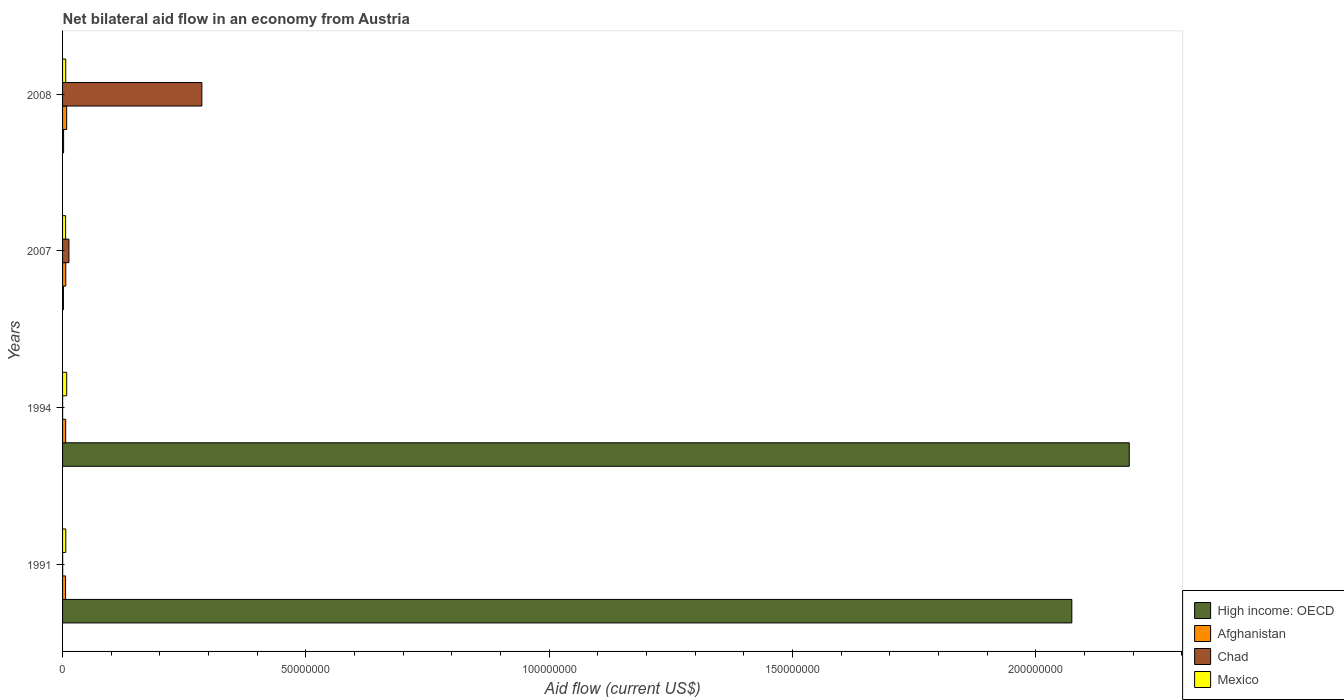How many different coloured bars are there?
Provide a succinct answer. 4. Are the number of bars per tick equal to the number of legend labels?
Provide a succinct answer. Yes. How many bars are there on the 4th tick from the bottom?
Offer a terse response. 4. What is the label of the 4th group of bars from the top?
Keep it short and to the point. 1991. In how many cases, is the number of bars for a given year not equal to the number of legend labels?
Provide a short and direct response. 0. Across all years, what is the maximum net bilateral aid flow in High income: OECD?
Ensure brevity in your answer.  2.19e+08. Across all years, what is the minimum net bilateral aid flow in Mexico?
Keep it short and to the point. 6.30e+05. In which year was the net bilateral aid flow in Afghanistan minimum?
Keep it short and to the point. 1991. What is the total net bilateral aid flow in Chad in the graph?
Ensure brevity in your answer.  3.00e+07. What is the difference between the net bilateral aid flow in Afghanistan in 1991 and that in 2008?
Make the answer very short. -2.20e+05. What is the difference between the net bilateral aid flow in Chad in 2008 and the net bilateral aid flow in Mexico in 2007?
Offer a terse response. 2.80e+07. What is the average net bilateral aid flow in Afghanistan per year?
Offer a terse response. 6.90e+05. In the year 1994, what is the difference between the net bilateral aid flow in Chad and net bilateral aid flow in Afghanistan?
Keep it short and to the point. -6.30e+05. What is the ratio of the net bilateral aid flow in Chad in 1991 to that in 1994?
Give a very brief answer. 2. What is the difference between the highest and the second highest net bilateral aid flow in Mexico?
Ensure brevity in your answer.  1.90e+05. What does the 4th bar from the top in 1991 represents?
Your answer should be compact. High income: OECD. What does the 3rd bar from the bottom in 1991 represents?
Offer a very short reply. Chad. How many bars are there?
Offer a terse response. 16. How many years are there in the graph?
Keep it short and to the point. 4. What is the difference between two consecutive major ticks on the X-axis?
Ensure brevity in your answer.  5.00e+07. Are the values on the major ticks of X-axis written in scientific E-notation?
Keep it short and to the point. No. Does the graph contain grids?
Make the answer very short. No. How are the legend labels stacked?
Your response must be concise. Vertical. What is the title of the graph?
Ensure brevity in your answer.  Net bilateral aid flow in an economy from Austria. What is the Aid flow (current US$) in High income: OECD in 1991?
Provide a short and direct response. 2.07e+08. What is the Aid flow (current US$) in Afghanistan in 1991?
Provide a succinct answer. 6.20e+05. What is the Aid flow (current US$) of Chad in 1991?
Keep it short and to the point. 2.00e+04. What is the Aid flow (current US$) in High income: OECD in 1994?
Your answer should be compact. 2.19e+08. What is the Aid flow (current US$) in Afghanistan in 1994?
Your answer should be compact. 6.40e+05. What is the Aid flow (current US$) of Mexico in 1994?
Keep it short and to the point. 8.50e+05. What is the Aid flow (current US$) of High income: OECD in 2007?
Your response must be concise. 1.80e+05. What is the Aid flow (current US$) in Chad in 2007?
Your answer should be very brief. 1.31e+06. What is the Aid flow (current US$) in Mexico in 2007?
Ensure brevity in your answer.  6.30e+05. What is the Aid flow (current US$) in High income: OECD in 2008?
Give a very brief answer. 2.10e+05. What is the Aid flow (current US$) of Afghanistan in 2008?
Provide a short and direct response. 8.40e+05. What is the Aid flow (current US$) of Chad in 2008?
Give a very brief answer. 2.86e+07. What is the Aid flow (current US$) in Mexico in 2008?
Your answer should be very brief. 6.50e+05. Across all years, what is the maximum Aid flow (current US$) in High income: OECD?
Your response must be concise. 2.19e+08. Across all years, what is the maximum Aid flow (current US$) in Afghanistan?
Give a very brief answer. 8.40e+05. Across all years, what is the maximum Aid flow (current US$) in Chad?
Your answer should be very brief. 2.86e+07. Across all years, what is the maximum Aid flow (current US$) in Mexico?
Your answer should be compact. 8.50e+05. Across all years, what is the minimum Aid flow (current US$) of High income: OECD?
Keep it short and to the point. 1.80e+05. Across all years, what is the minimum Aid flow (current US$) of Afghanistan?
Offer a terse response. 6.20e+05. Across all years, what is the minimum Aid flow (current US$) of Mexico?
Your answer should be very brief. 6.30e+05. What is the total Aid flow (current US$) of High income: OECD in the graph?
Your answer should be compact. 4.27e+08. What is the total Aid flow (current US$) in Afghanistan in the graph?
Provide a succinct answer. 2.76e+06. What is the total Aid flow (current US$) of Chad in the graph?
Offer a terse response. 3.00e+07. What is the total Aid flow (current US$) in Mexico in the graph?
Your answer should be very brief. 2.79e+06. What is the difference between the Aid flow (current US$) in High income: OECD in 1991 and that in 1994?
Offer a terse response. -1.18e+07. What is the difference between the Aid flow (current US$) of High income: OECD in 1991 and that in 2007?
Provide a short and direct response. 2.07e+08. What is the difference between the Aid flow (current US$) in Chad in 1991 and that in 2007?
Keep it short and to the point. -1.29e+06. What is the difference between the Aid flow (current US$) of High income: OECD in 1991 and that in 2008?
Your response must be concise. 2.07e+08. What is the difference between the Aid flow (current US$) of Chad in 1991 and that in 2008?
Make the answer very short. -2.86e+07. What is the difference between the Aid flow (current US$) in High income: OECD in 1994 and that in 2007?
Your answer should be compact. 2.19e+08. What is the difference between the Aid flow (current US$) of Afghanistan in 1994 and that in 2007?
Your answer should be compact. -2.00e+04. What is the difference between the Aid flow (current US$) in Chad in 1994 and that in 2007?
Offer a very short reply. -1.30e+06. What is the difference between the Aid flow (current US$) in High income: OECD in 1994 and that in 2008?
Your answer should be very brief. 2.19e+08. What is the difference between the Aid flow (current US$) in Afghanistan in 1994 and that in 2008?
Provide a short and direct response. -2.00e+05. What is the difference between the Aid flow (current US$) of Chad in 1994 and that in 2008?
Offer a very short reply. -2.86e+07. What is the difference between the Aid flow (current US$) in Mexico in 1994 and that in 2008?
Provide a succinct answer. 2.00e+05. What is the difference between the Aid flow (current US$) in Afghanistan in 2007 and that in 2008?
Ensure brevity in your answer.  -1.80e+05. What is the difference between the Aid flow (current US$) of Chad in 2007 and that in 2008?
Offer a very short reply. -2.73e+07. What is the difference between the Aid flow (current US$) of High income: OECD in 1991 and the Aid flow (current US$) of Afghanistan in 1994?
Your response must be concise. 2.07e+08. What is the difference between the Aid flow (current US$) in High income: OECD in 1991 and the Aid flow (current US$) in Chad in 1994?
Your answer should be compact. 2.07e+08. What is the difference between the Aid flow (current US$) in High income: OECD in 1991 and the Aid flow (current US$) in Mexico in 1994?
Ensure brevity in your answer.  2.07e+08. What is the difference between the Aid flow (current US$) in Chad in 1991 and the Aid flow (current US$) in Mexico in 1994?
Provide a short and direct response. -8.30e+05. What is the difference between the Aid flow (current US$) in High income: OECD in 1991 and the Aid flow (current US$) in Afghanistan in 2007?
Make the answer very short. 2.07e+08. What is the difference between the Aid flow (current US$) of High income: OECD in 1991 and the Aid flow (current US$) of Chad in 2007?
Offer a terse response. 2.06e+08. What is the difference between the Aid flow (current US$) of High income: OECD in 1991 and the Aid flow (current US$) of Mexico in 2007?
Make the answer very short. 2.07e+08. What is the difference between the Aid flow (current US$) of Afghanistan in 1991 and the Aid flow (current US$) of Chad in 2007?
Ensure brevity in your answer.  -6.90e+05. What is the difference between the Aid flow (current US$) of Chad in 1991 and the Aid flow (current US$) of Mexico in 2007?
Give a very brief answer. -6.10e+05. What is the difference between the Aid flow (current US$) in High income: OECD in 1991 and the Aid flow (current US$) in Afghanistan in 2008?
Provide a succinct answer. 2.07e+08. What is the difference between the Aid flow (current US$) of High income: OECD in 1991 and the Aid flow (current US$) of Chad in 2008?
Your answer should be very brief. 1.79e+08. What is the difference between the Aid flow (current US$) of High income: OECD in 1991 and the Aid flow (current US$) of Mexico in 2008?
Ensure brevity in your answer.  2.07e+08. What is the difference between the Aid flow (current US$) in Afghanistan in 1991 and the Aid flow (current US$) in Chad in 2008?
Make the answer very short. -2.80e+07. What is the difference between the Aid flow (current US$) in Chad in 1991 and the Aid flow (current US$) in Mexico in 2008?
Provide a short and direct response. -6.30e+05. What is the difference between the Aid flow (current US$) of High income: OECD in 1994 and the Aid flow (current US$) of Afghanistan in 2007?
Give a very brief answer. 2.19e+08. What is the difference between the Aid flow (current US$) of High income: OECD in 1994 and the Aid flow (current US$) of Chad in 2007?
Offer a terse response. 2.18e+08. What is the difference between the Aid flow (current US$) of High income: OECD in 1994 and the Aid flow (current US$) of Mexico in 2007?
Ensure brevity in your answer.  2.19e+08. What is the difference between the Aid flow (current US$) in Afghanistan in 1994 and the Aid flow (current US$) in Chad in 2007?
Offer a very short reply. -6.70e+05. What is the difference between the Aid flow (current US$) in Afghanistan in 1994 and the Aid flow (current US$) in Mexico in 2007?
Provide a succinct answer. 10000. What is the difference between the Aid flow (current US$) in Chad in 1994 and the Aid flow (current US$) in Mexico in 2007?
Your response must be concise. -6.20e+05. What is the difference between the Aid flow (current US$) of High income: OECD in 1994 and the Aid flow (current US$) of Afghanistan in 2008?
Provide a succinct answer. 2.18e+08. What is the difference between the Aid flow (current US$) of High income: OECD in 1994 and the Aid flow (current US$) of Chad in 2008?
Provide a succinct answer. 1.91e+08. What is the difference between the Aid flow (current US$) in High income: OECD in 1994 and the Aid flow (current US$) in Mexico in 2008?
Keep it short and to the point. 2.19e+08. What is the difference between the Aid flow (current US$) of Afghanistan in 1994 and the Aid flow (current US$) of Chad in 2008?
Your answer should be very brief. -2.80e+07. What is the difference between the Aid flow (current US$) of Chad in 1994 and the Aid flow (current US$) of Mexico in 2008?
Give a very brief answer. -6.40e+05. What is the difference between the Aid flow (current US$) of High income: OECD in 2007 and the Aid flow (current US$) of Afghanistan in 2008?
Offer a very short reply. -6.60e+05. What is the difference between the Aid flow (current US$) in High income: OECD in 2007 and the Aid flow (current US$) in Chad in 2008?
Give a very brief answer. -2.84e+07. What is the difference between the Aid flow (current US$) of High income: OECD in 2007 and the Aid flow (current US$) of Mexico in 2008?
Your response must be concise. -4.70e+05. What is the difference between the Aid flow (current US$) of Afghanistan in 2007 and the Aid flow (current US$) of Chad in 2008?
Your answer should be very brief. -2.80e+07. What is the difference between the Aid flow (current US$) in Afghanistan in 2007 and the Aid flow (current US$) in Mexico in 2008?
Your answer should be compact. 10000. What is the difference between the Aid flow (current US$) of Chad in 2007 and the Aid flow (current US$) of Mexico in 2008?
Your answer should be compact. 6.60e+05. What is the average Aid flow (current US$) of High income: OECD per year?
Give a very brief answer. 1.07e+08. What is the average Aid flow (current US$) in Afghanistan per year?
Provide a short and direct response. 6.90e+05. What is the average Aid flow (current US$) in Chad per year?
Your response must be concise. 7.49e+06. What is the average Aid flow (current US$) of Mexico per year?
Offer a terse response. 6.98e+05. In the year 1991, what is the difference between the Aid flow (current US$) of High income: OECD and Aid flow (current US$) of Afghanistan?
Provide a short and direct response. 2.07e+08. In the year 1991, what is the difference between the Aid flow (current US$) of High income: OECD and Aid flow (current US$) of Chad?
Make the answer very short. 2.07e+08. In the year 1991, what is the difference between the Aid flow (current US$) of High income: OECD and Aid flow (current US$) of Mexico?
Your answer should be compact. 2.07e+08. In the year 1991, what is the difference between the Aid flow (current US$) of Afghanistan and Aid flow (current US$) of Chad?
Keep it short and to the point. 6.00e+05. In the year 1991, what is the difference between the Aid flow (current US$) in Afghanistan and Aid flow (current US$) in Mexico?
Offer a very short reply. -4.00e+04. In the year 1991, what is the difference between the Aid flow (current US$) of Chad and Aid flow (current US$) of Mexico?
Make the answer very short. -6.40e+05. In the year 1994, what is the difference between the Aid flow (current US$) in High income: OECD and Aid flow (current US$) in Afghanistan?
Ensure brevity in your answer.  2.19e+08. In the year 1994, what is the difference between the Aid flow (current US$) in High income: OECD and Aid flow (current US$) in Chad?
Your response must be concise. 2.19e+08. In the year 1994, what is the difference between the Aid flow (current US$) of High income: OECD and Aid flow (current US$) of Mexico?
Ensure brevity in your answer.  2.18e+08. In the year 1994, what is the difference between the Aid flow (current US$) in Afghanistan and Aid flow (current US$) in Chad?
Provide a succinct answer. 6.30e+05. In the year 1994, what is the difference between the Aid flow (current US$) in Chad and Aid flow (current US$) in Mexico?
Provide a succinct answer. -8.40e+05. In the year 2007, what is the difference between the Aid flow (current US$) in High income: OECD and Aid flow (current US$) in Afghanistan?
Ensure brevity in your answer.  -4.80e+05. In the year 2007, what is the difference between the Aid flow (current US$) of High income: OECD and Aid flow (current US$) of Chad?
Your answer should be very brief. -1.13e+06. In the year 2007, what is the difference between the Aid flow (current US$) of High income: OECD and Aid flow (current US$) of Mexico?
Your answer should be very brief. -4.50e+05. In the year 2007, what is the difference between the Aid flow (current US$) of Afghanistan and Aid flow (current US$) of Chad?
Give a very brief answer. -6.50e+05. In the year 2007, what is the difference between the Aid flow (current US$) in Afghanistan and Aid flow (current US$) in Mexico?
Your answer should be very brief. 3.00e+04. In the year 2007, what is the difference between the Aid flow (current US$) in Chad and Aid flow (current US$) in Mexico?
Your answer should be very brief. 6.80e+05. In the year 2008, what is the difference between the Aid flow (current US$) of High income: OECD and Aid flow (current US$) of Afghanistan?
Make the answer very short. -6.30e+05. In the year 2008, what is the difference between the Aid flow (current US$) of High income: OECD and Aid flow (current US$) of Chad?
Your answer should be very brief. -2.84e+07. In the year 2008, what is the difference between the Aid flow (current US$) in High income: OECD and Aid flow (current US$) in Mexico?
Keep it short and to the point. -4.40e+05. In the year 2008, what is the difference between the Aid flow (current US$) of Afghanistan and Aid flow (current US$) of Chad?
Give a very brief answer. -2.78e+07. In the year 2008, what is the difference between the Aid flow (current US$) in Chad and Aid flow (current US$) in Mexico?
Give a very brief answer. 2.80e+07. What is the ratio of the Aid flow (current US$) of High income: OECD in 1991 to that in 1994?
Give a very brief answer. 0.95. What is the ratio of the Aid flow (current US$) of Afghanistan in 1991 to that in 1994?
Your response must be concise. 0.97. What is the ratio of the Aid flow (current US$) of Mexico in 1991 to that in 1994?
Keep it short and to the point. 0.78. What is the ratio of the Aid flow (current US$) of High income: OECD in 1991 to that in 2007?
Provide a succinct answer. 1152.06. What is the ratio of the Aid flow (current US$) of Afghanistan in 1991 to that in 2007?
Your response must be concise. 0.94. What is the ratio of the Aid flow (current US$) in Chad in 1991 to that in 2007?
Provide a succinct answer. 0.02. What is the ratio of the Aid flow (current US$) in Mexico in 1991 to that in 2007?
Your response must be concise. 1.05. What is the ratio of the Aid flow (current US$) in High income: OECD in 1991 to that in 2008?
Your answer should be compact. 987.48. What is the ratio of the Aid flow (current US$) of Afghanistan in 1991 to that in 2008?
Give a very brief answer. 0.74. What is the ratio of the Aid flow (current US$) in Chad in 1991 to that in 2008?
Provide a succinct answer. 0. What is the ratio of the Aid flow (current US$) in Mexico in 1991 to that in 2008?
Ensure brevity in your answer.  1.02. What is the ratio of the Aid flow (current US$) in High income: OECD in 1994 to that in 2007?
Your answer should be compact. 1217.61. What is the ratio of the Aid flow (current US$) in Afghanistan in 1994 to that in 2007?
Your response must be concise. 0.97. What is the ratio of the Aid flow (current US$) in Chad in 1994 to that in 2007?
Keep it short and to the point. 0.01. What is the ratio of the Aid flow (current US$) of Mexico in 1994 to that in 2007?
Ensure brevity in your answer.  1.35. What is the ratio of the Aid flow (current US$) of High income: OECD in 1994 to that in 2008?
Your answer should be very brief. 1043.67. What is the ratio of the Aid flow (current US$) in Afghanistan in 1994 to that in 2008?
Offer a very short reply. 0.76. What is the ratio of the Aid flow (current US$) in Mexico in 1994 to that in 2008?
Provide a short and direct response. 1.31. What is the ratio of the Aid flow (current US$) in Afghanistan in 2007 to that in 2008?
Make the answer very short. 0.79. What is the ratio of the Aid flow (current US$) of Chad in 2007 to that in 2008?
Provide a succinct answer. 0.05. What is the ratio of the Aid flow (current US$) of Mexico in 2007 to that in 2008?
Provide a succinct answer. 0.97. What is the difference between the highest and the second highest Aid flow (current US$) in High income: OECD?
Offer a terse response. 1.18e+07. What is the difference between the highest and the second highest Aid flow (current US$) in Chad?
Your response must be concise. 2.73e+07. What is the difference between the highest and the lowest Aid flow (current US$) in High income: OECD?
Offer a terse response. 2.19e+08. What is the difference between the highest and the lowest Aid flow (current US$) of Chad?
Offer a terse response. 2.86e+07. What is the difference between the highest and the lowest Aid flow (current US$) in Mexico?
Your answer should be compact. 2.20e+05. 